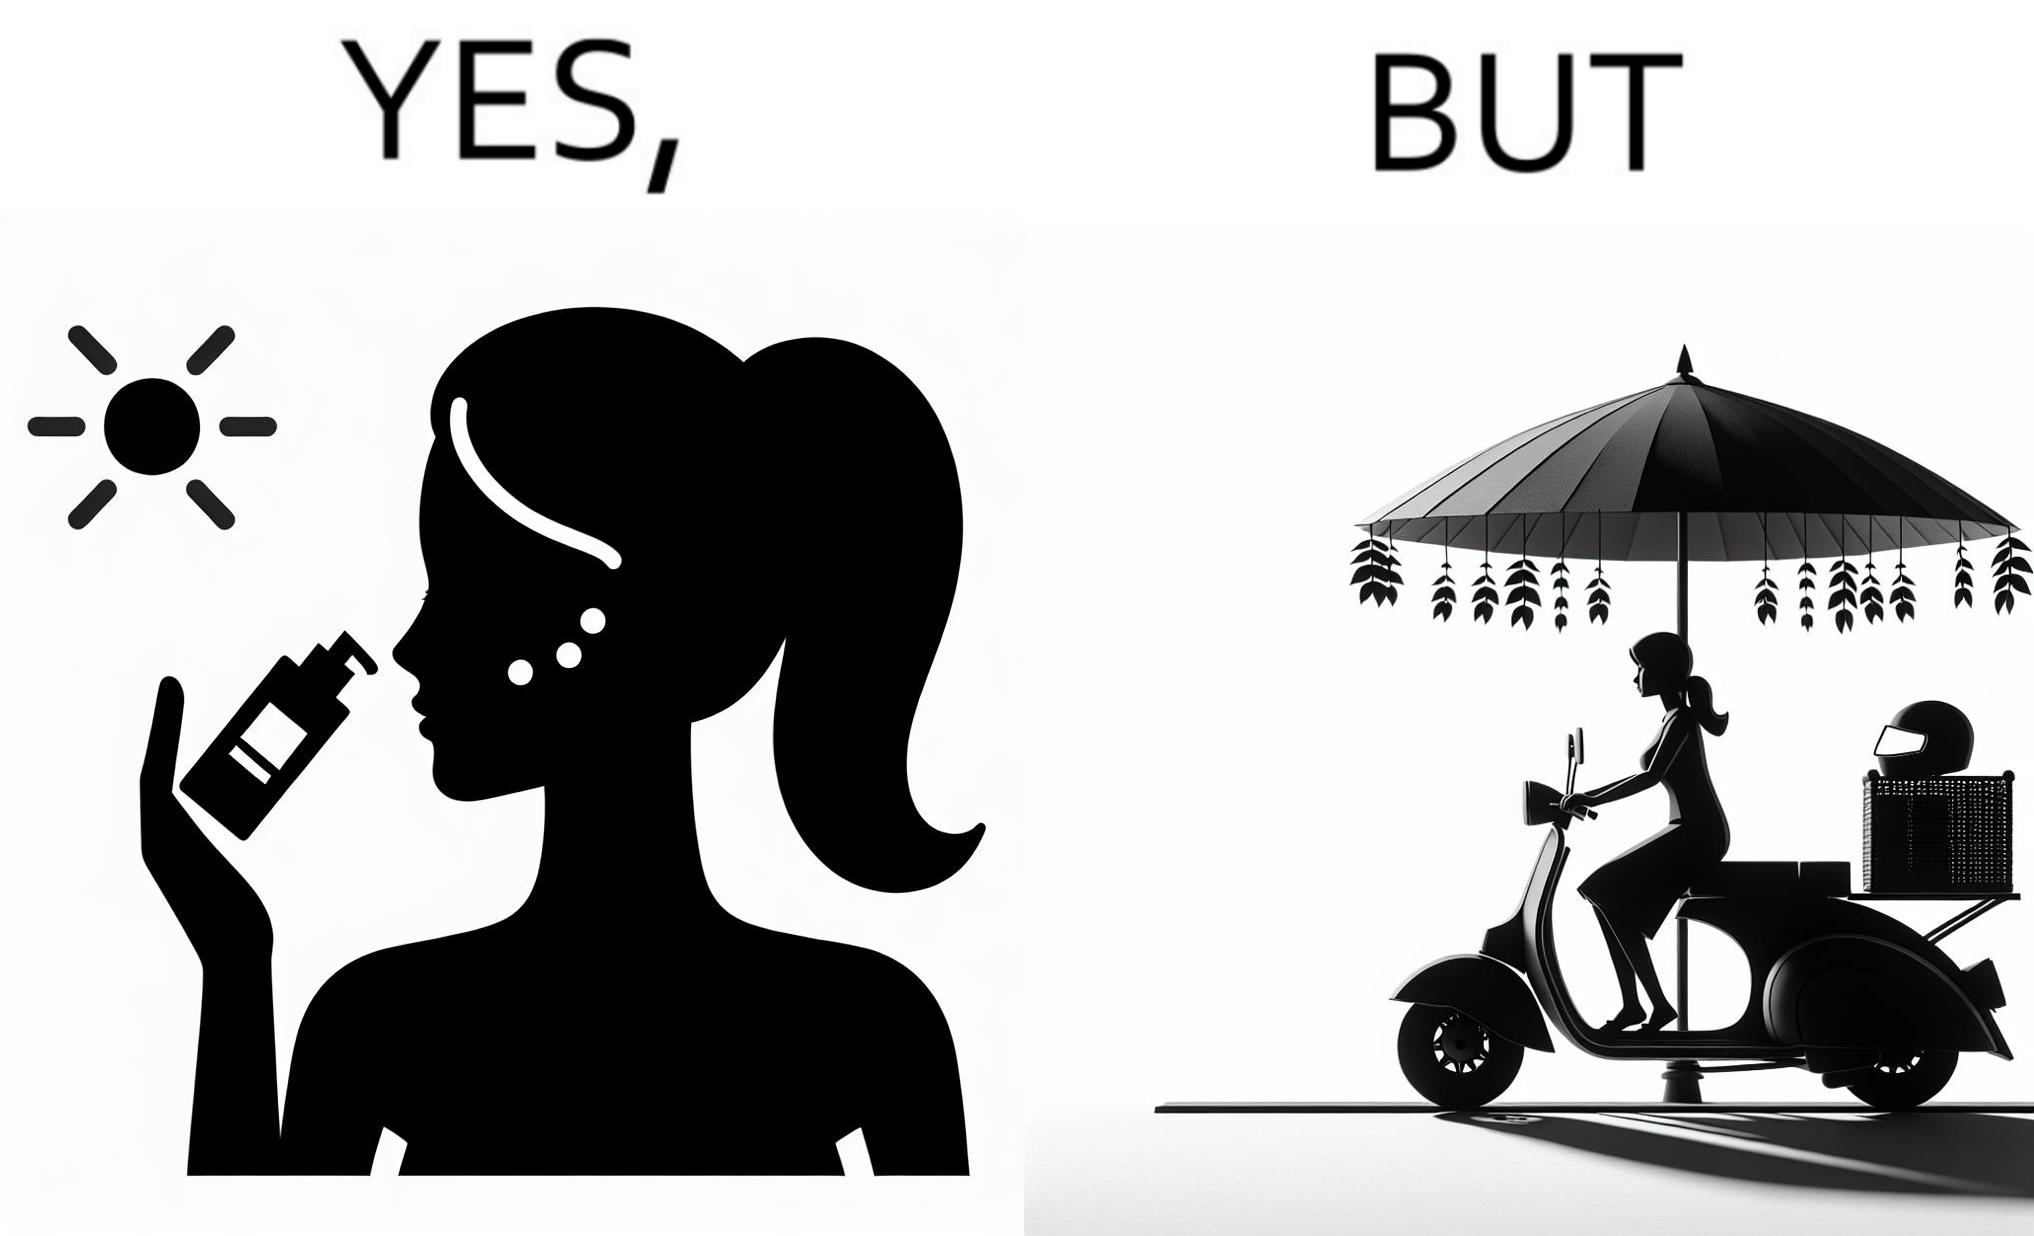Describe what you see in the left and right parts of this image. In the left part of the image: The image shows a woman applying sunscreen with high SPF on her face. In the right part of the image: The image shows a woman riding a scooter with her helmet on the back seat. 